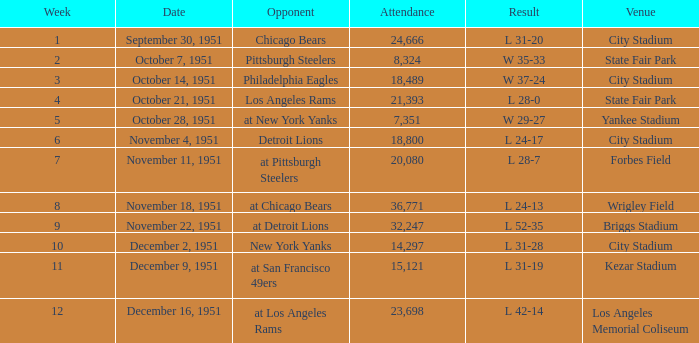Which date's week was more than 4 with the venue being City Stadium and where the attendance was more than 14,297? November 4, 1951. 